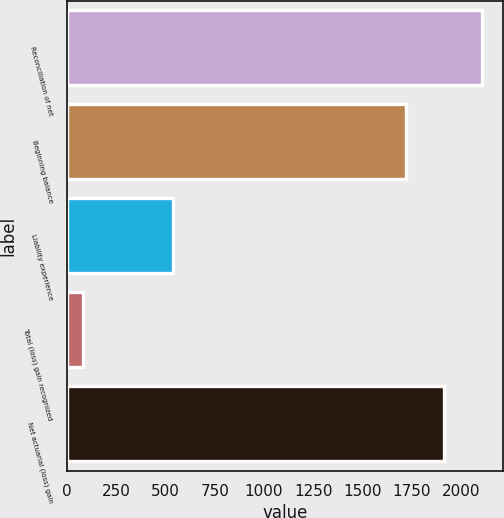Convert chart. <chart><loc_0><loc_0><loc_500><loc_500><bar_chart><fcel>Reconciliation of net<fcel>Beginning balance<fcel>Liability experience<fcel>Total (loss) gain recognized<fcel>Net actuarial (loss) gain<nl><fcel>2106.8<fcel>1720<fcel>538<fcel>83<fcel>1913.4<nl></chart> 